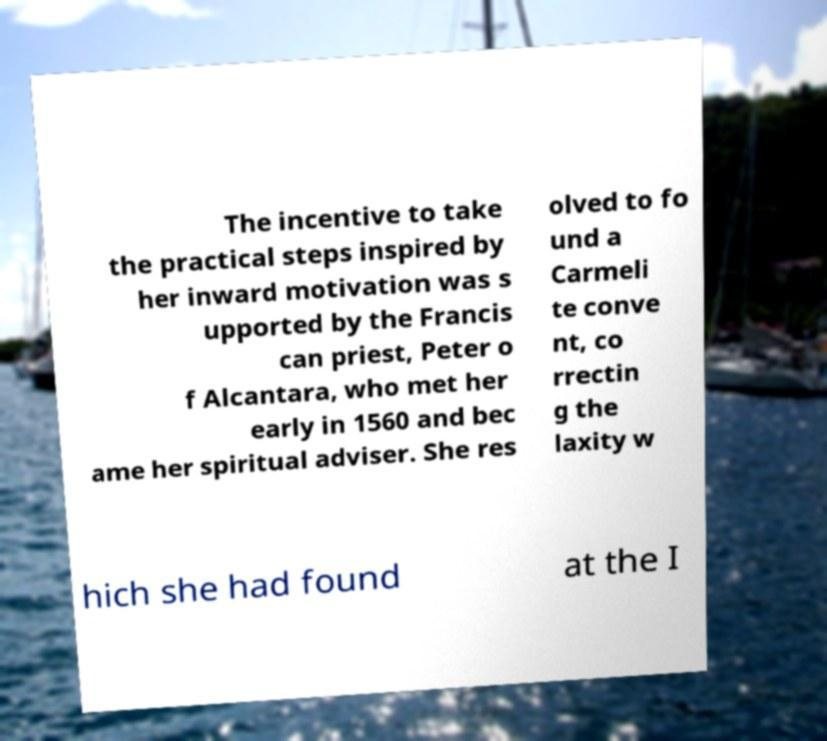It looks like this text is about a historical figure. Can you tell me more about the person being described here? The text mentions a Franciscan priest and refers to efforts to found a Carmelite convent, correct laxity, and involves a meeting in 1560. This might be related to Saint Teresa of Ávila, a prominent Spanish mystic who reformed the Carmelite Order. Her association with Peter of Alcantara, who was indeed a Franciscan priest, and her work in founding convents that practiced strict adherence to the Carmelite rule align well with the content of the image. 